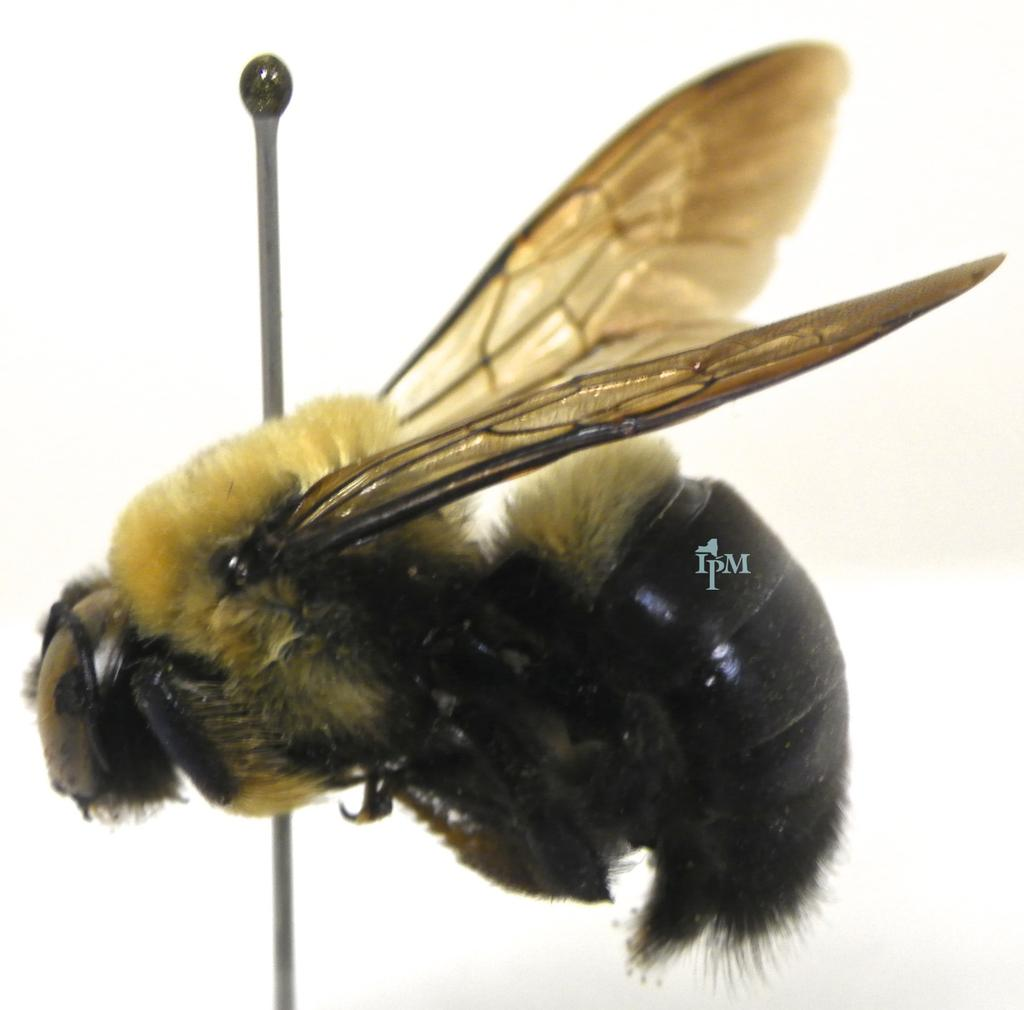What type of insects are in the image? There are net-winged insects in the image. Where are the insects located in the image? The insects are in the center of the image. What type of hair is visible on the insects in the image? There is no hair visible on the insects in the image, as insects do not have hair. 